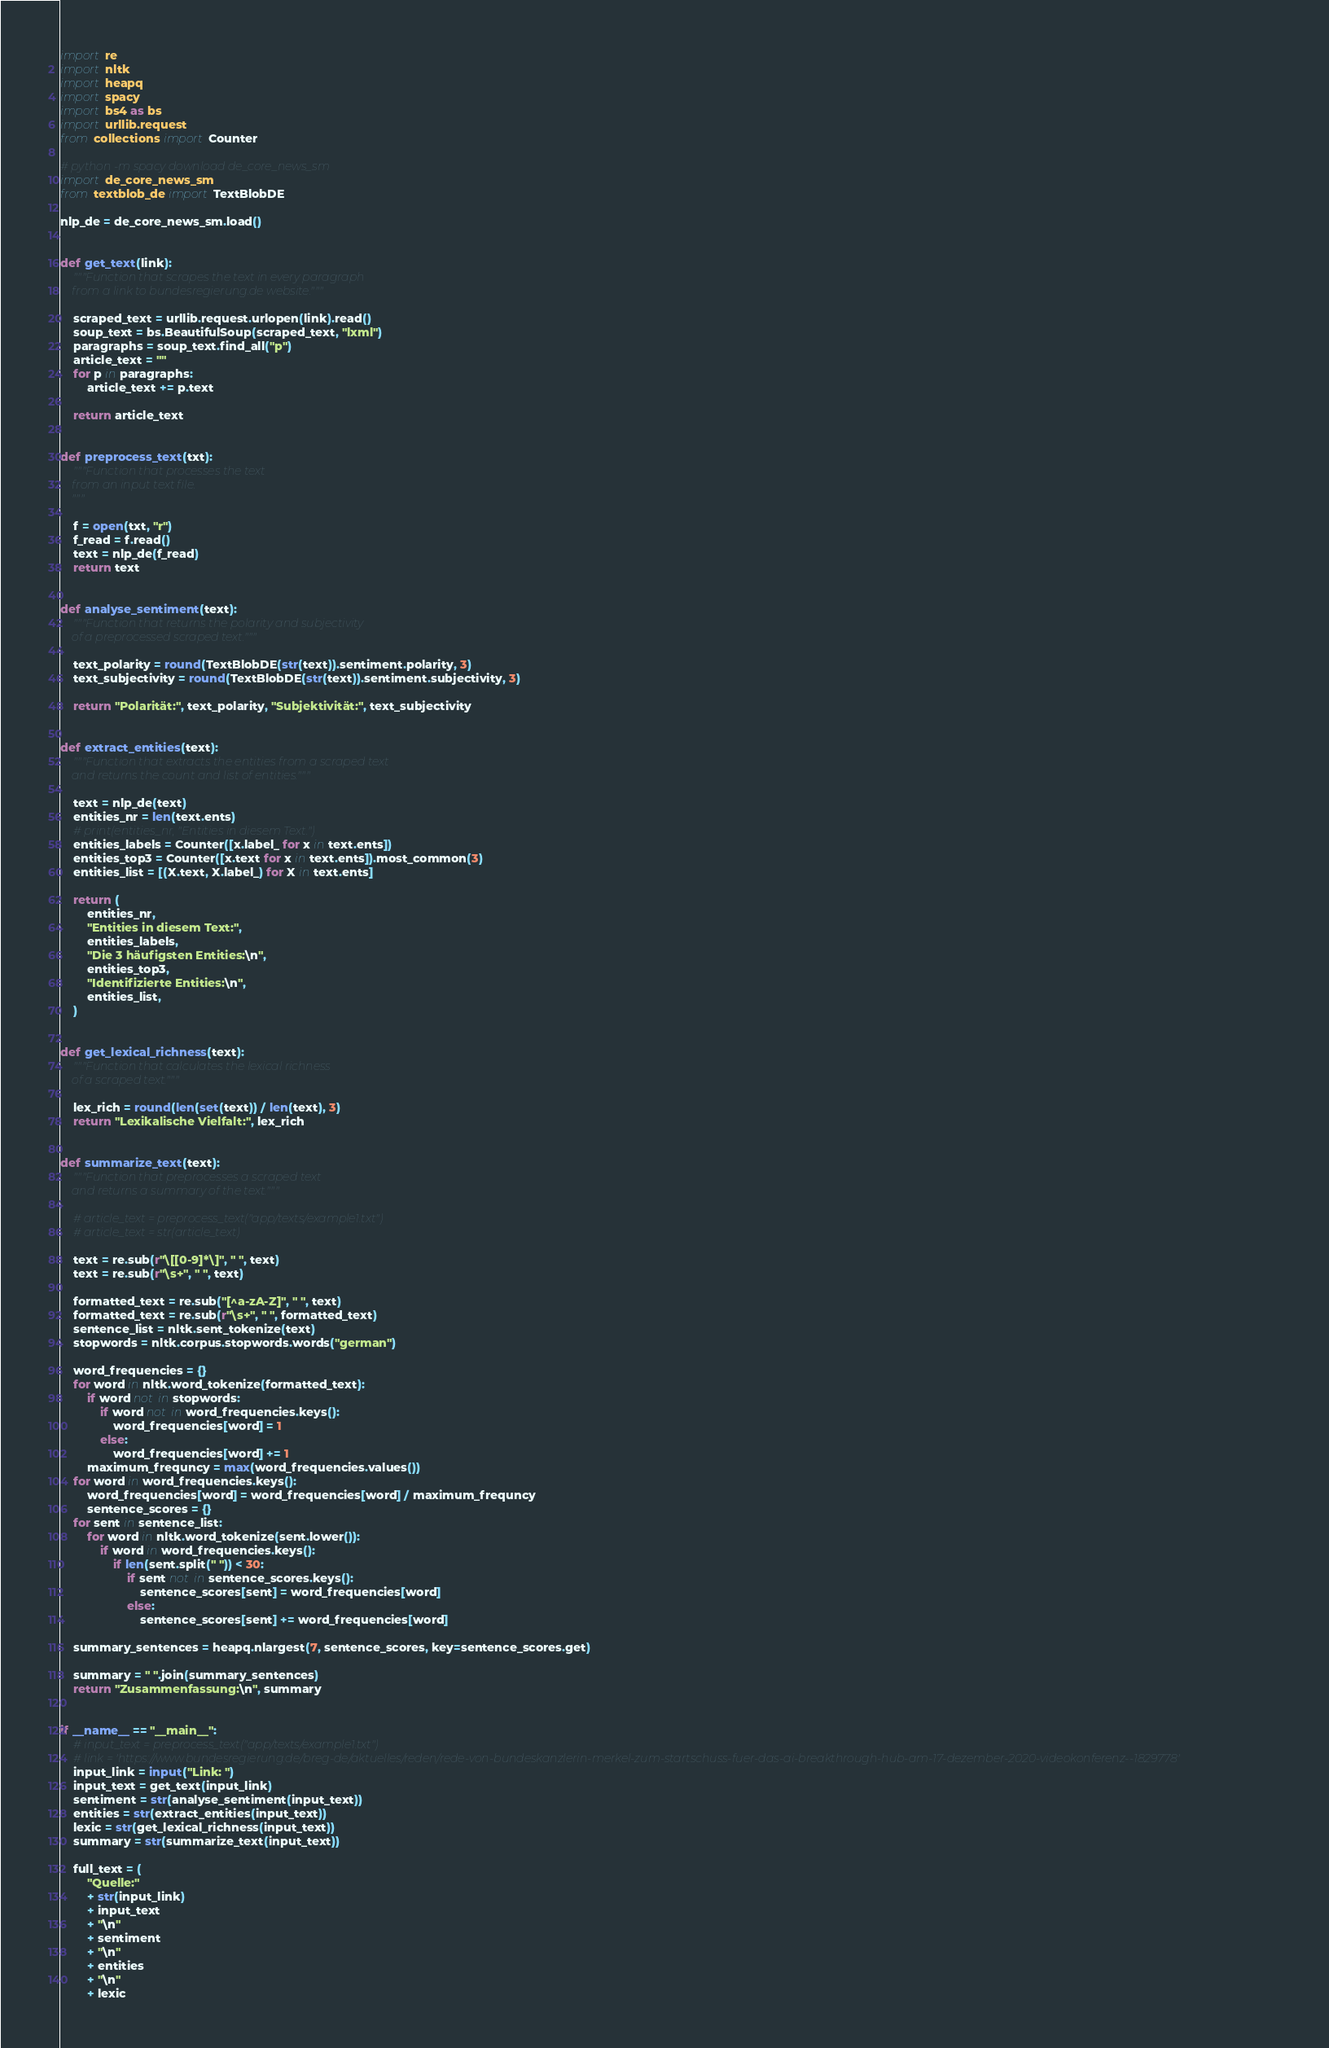<code> <loc_0><loc_0><loc_500><loc_500><_Python_>import re
import nltk
import heapq
import spacy
import bs4 as bs
import urllib.request
from collections import Counter

# python -m spacy download de_core_news_sm
import de_core_news_sm
from textblob_de import TextBlobDE

nlp_de = de_core_news_sm.load()


def get_text(link):
    """Function that scrapes the text in every paragraph
    from a link to bundesregierung.de website."""

    scraped_text = urllib.request.urlopen(link).read()
    soup_text = bs.BeautifulSoup(scraped_text, "lxml")
    paragraphs = soup_text.find_all("p")
    article_text = ""
    for p in paragraphs:
        article_text += p.text

    return article_text


def preprocess_text(txt):
    """Function that processes the text
    from an input text file.
    """

    f = open(txt, "r")
    f_read = f.read()
    text = nlp_de(f_read)
    return text


def analyse_sentiment(text):
    """Function that returns the polarity and subjectivity
    of a preprocessed scraped text."""

    text_polarity = round(TextBlobDE(str(text)).sentiment.polarity, 3)
    text_subjectivity = round(TextBlobDE(str(text)).sentiment.subjectivity, 3)

    return "Polarität:", text_polarity, "Subjektivität:", text_subjectivity


def extract_entities(text):
    """Function that extracts the entities from a scraped text
    and returns the count and list of entities."""

    text = nlp_de(text)
    entities_nr = len(text.ents)
    # print(entities_nr, "Entities in diesem Text.")
    entities_labels = Counter([x.label_ for x in text.ents])
    entities_top3 = Counter([x.text for x in text.ents]).most_common(3)
    entities_list = [(X.text, X.label_) for X in text.ents]

    return (
        entities_nr,
        "Entities in diesem Text:",
        entities_labels,
        "Die 3 häufigsten Entities:\n",
        entities_top3,
        "Identifizierte Entities:\n",
        entities_list,
    )


def get_lexical_richness(text):
    """Function that calculates the lexical richness
    of a scraped text."""

    lex_rich = round(len(set(text)) / len(text), 3)
    return "Lexikalische Vielfalt:", lex_rich


def summarize_text(text):
    """Function that preprocesses a scraped text
    and returns a summary of the text."""

    # article_text = preprocess_text("app/texts/example1.txt")
    # article_text = str(article_text)

    text = re.sub(r"\[[0-9]*\]", " ", text)
    text = re.sub(r"\s+", " ", text)

    formatted_text = re.sub("[^a-zA-Z]", " ", text)
    formatted_text = re.sub(r"\s+", " ", formatted_text)
    sentence_list = nltk.sent_tokenize(text)
    stopwords = nltk.corpus.stopwords.words("german")

    word_frequencies = {}
    for word in nltk.word_tokenize(formatted_text):
        if word not in stopwords:
            if word not in word_frequencies.keys():
                word_frequencies[word] = 1
            else:
                word_frequencies[word] += 1
        maximum_frequncy = max(word_frequencies.values())
    for word in word_frequencies.keys():
        word_frequencies[word] = word_frequencies[word] / maximum_frequncy
        sentence_scores = {}
    for sent in sentence_list:
        for word in nltk.word_tokenize(sent.lower()):
            if word in word_frequencies.keys():
                if len(sent.split(" ")) < 30:
                    if sent not in sentence_scores.keys():
                        sentence_scores[sent] = word_frequencies[word]
                    else:
                        sentence_scores[sent] += word_frequencies[word]

    summary_sentences = heapq.nlargest(7, sentence_scores, key=sentence_scores.get)

    summary = " ".join(summary_sentences)
    return "Zusammenfassung:\n", summary


if __name__ == "__main__":
    # input_text = preprocess_text("app/texts/example1.txt")
    # link = 'https://www.bundesregierung.de/breg-de/aktuelles/reden/rede-von-bundeskanzlerin-merkel-zum-startschuss-fuer-das-ai-breakthrough-hub-am-17-dezember-2020-videokonferenz--1829778'
    input_link = input("Link: ")
    input_text = get_text(input_link)
    sentiment = str(analyse_sentiment(input_text))
    entities = str(extract_entities(input_text))
    lexic = str(get_lexical_richness(input_text))
    summary = str(summarize_text(input_text))

    full_text = (
        "Quelle:"
        + str(input_link)
        + input_text
        + "\n"
        + sentiment
        + "\n"
        + entities
        + "\n"
        + lexic</code> 